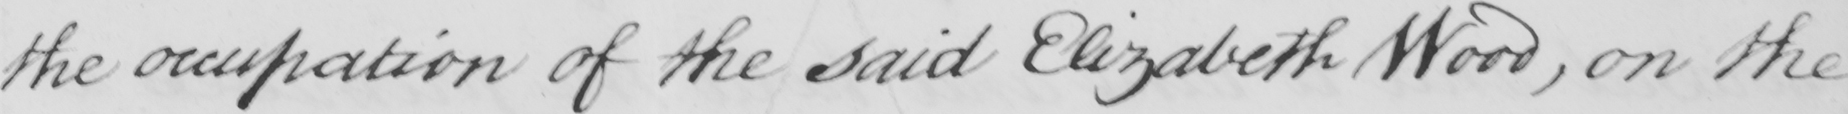Please transcribe the handwritten text in this image. the occupation of the said Elizabeth Wood , on the 